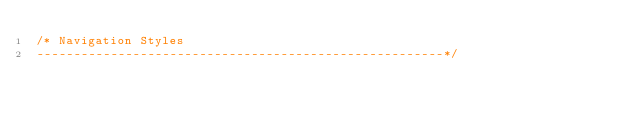Convert code to text. <code><loc_0><loc_0><loc_500><loc_500><_CSS_>/* Navigation Styles
-------------------------------------------------------*/</code> 